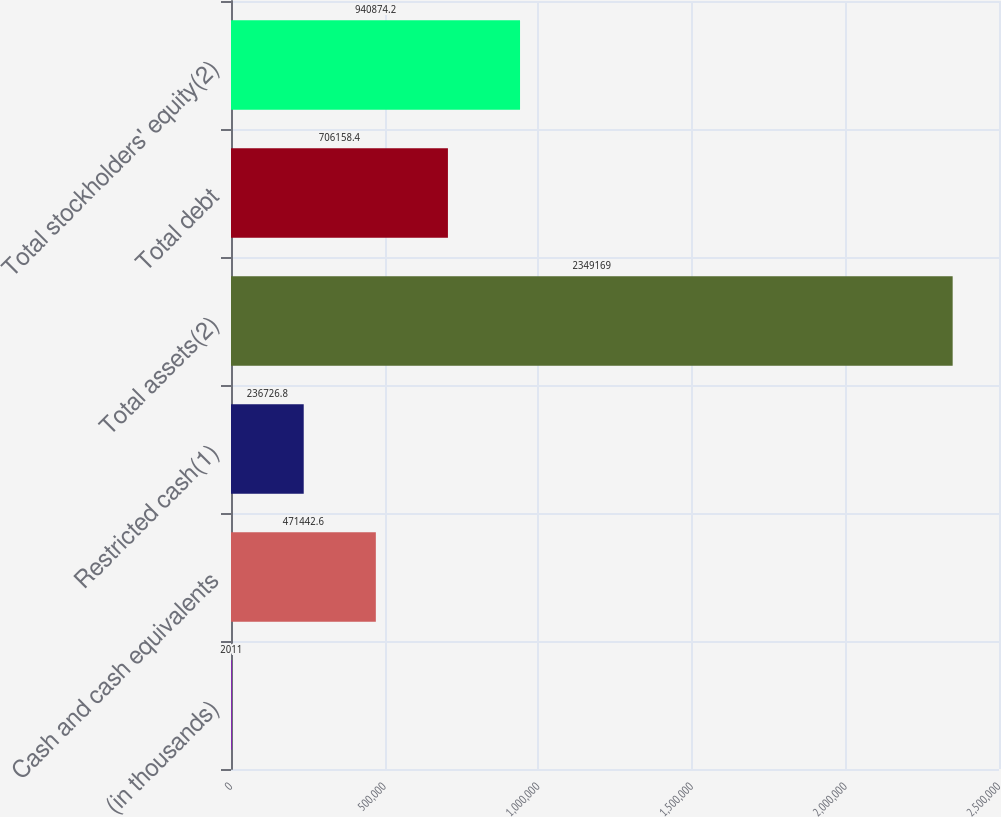<chart> <loc_0><loc_0><loc_500><loc_500><bar_chart><fcel>(in thousands)<fcel>Cash and cash equivalents<fcel>Restricted cash(1)<fcel>Total assets(2)<fcel>Total debt<fcel>Total stockholders' equity(2)<nl><fcel>2011<fcel>471443<fcel>236727<fcel>2.34917e+06<fcel>706158<fcel>940874<nl></chart> 